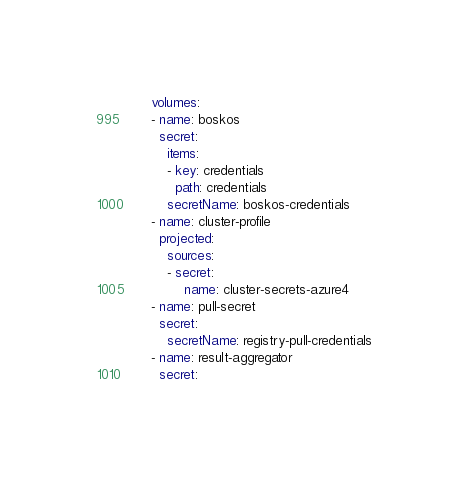Convert code to text. <code><loc_0><loc_0><loc_500><loc_500><_YAML_>      volumes:
      - name: boskos
        secret:
          items:
          - key: credentials
            path: credentials
          secretName: boskos-credentials
      - name: cluster-profile
        projected:
          sources:
          - secret:
              name: cluster-secrets-azure4
      - name: pull-secret
        secret:
          secretName: registry-pull-credentials
      - name: result-aggregator
        secret:</code> 